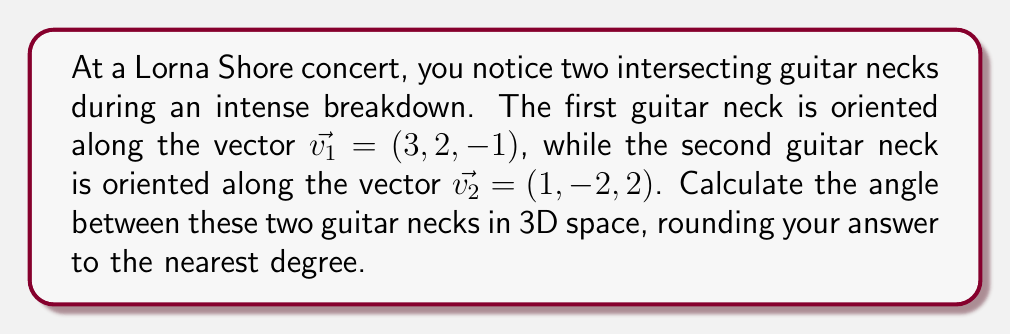Can you answer this question? To find the angle between two vectors in 3D space, we can use the dot product formula:

$$\cos \theta = \frac{\vec{v_1} \cdot \vec{v_2}}{|\vec{v_1}| |\vec{v_2}|}$$

Where $\theta$ is the angle between the vectors, $\vec{v_1} \cdot \vec{v_2}$ is the dot product of the vectors, and $|\vec{v_1}|$ and $|\vec{v_2}|$ are the magnitudes of the vectors.

Step 1: Calculate the dot product $\vec{v_1} \cdot \vec{v_2}$
$$\vec{v_1} \cdot \vec{v_2} = (3)(1) + (2)(-2) + (-1)(2) = 3 - 4 - 2 = -3$$

Step 2: Calculate the magnitudes of the vectors
$$|\vec{v_1}| = \sqrt{3^2 + 2^2 + (-1)^2} = \sqrt{14}$$
$$|\vec{v_2}| = \sqrt{1^2 + (-2)^2 + 2^2} = 3$$

Step 3: Substitute into the dot product formula
$$\cos \theta = \frac{-3}{(\sqrt{14})(3)}$$

Step 4: Solve for $\theta$ using the inverse cosine (arccos) function
$$\theta = \arccos\left(\frac{-3}{(\sqrt{14})(3)}\right)$$

Step 5: Calculate the result and round to the nearest degree
$$\theta \approx 106.60^\circ \approx 107^\circ$$

[asy]
import geometry;

size(200);
currentprojection=perspective(6,3,2);

draw(O--3X--3X+2Y--2Y--O--Z,gray);
draw(O--3X,blue,Arrow3);
draw(O--2Y,blue,Arrow3);
draw(O--Z,blue,Arrow3);

draw(O--(3,2,-1),red,Arrow3);
draw(O--(1,-2,2),green,Arrow3);

label("$\vec{v_1}$",(3,2,-1),NE);
label("$\vec{v_2}$",(1,-2,2),SW);

dot(O);
[/asy]
Answer: The angle between the two guitar necks is approximately 107°. 